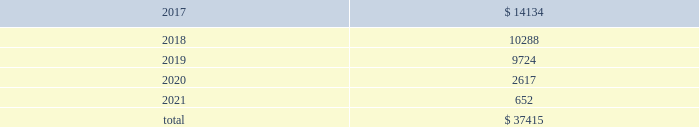Table of contents 17 .
Unconditional purchase obligations the company has entered into various unconditional purchase obligations which primarily include software licenses and long- term purchase contracts for network , communication and office maintenance services .
The company expended $ 7.2 million , $ 5.3 million and $ 2.9 million related to unconditional purchase obligations that existed as of the beginning of each year for the years ended december 31 , 2016 , 2015 and 2014 , respectively .
Future expenditures under unconditional purchase obligations in effect as of december 31 , 2016 are as follows : ( in thousands ) .
18 .
Restructuring during the fourth quarter of 2016 , the company initiated workforce realignment activities .
The company incurred $ 3.4 million in restructuring charges , or $ 2.4 million net of tax , during the year ended december 31 , 2016 .
The company expects to incur additional charges of $ 10 million - $ 15 million , or $ 7 million - $ 10 million net of tax , primarily during the first quarter of 2017 .
19 .
Employment-related settlement on february 15 , 2017 , the company entered into an employment-related settlement agreement .
In connection with the settlement agreement , the company will make a lump-sum payment of $ 4.7 million .
The charges related to this agreement are included in selling , general and administrative expense in the 2016 consolidated statement of income .
As part of the settlement agreement , all the claims initiated against the company will be withdrawn and a general release of all claims in favor of the company and all of its related entities was executed .
20 .
Contingencies and commitments the company is subject to various investigations , claims and legal proceedings that arise in the ordinary course of business , including commercial disputes , labor and employment matters , tax audits , alleged infringement of intellectual property rights and other matters .
In the opinion of the company , the resolution of pending matters is not expected to have a material adverse effect on the company's consolidated results of operations , cash flows or financial position .
However , each of these matters is subject to various uncertainties and it is possible that an unfavorable resolution of one or more of these proceedings could materially affect the company's results of operations , cash flows or financial position .
An indian subsidiary of the company has several service tax audits pending that have resulted in formal inquiries being received on transactions through mid-2012 .
The company could incur tax charges and related liabilities , including those related to the service tax audit case , of approximately $ 7 million .
The service tax issues raised in the company 2019s notices and inquiries are very similar to the case , m/s microsoft corporation ( i ) ( p ) ltd .
Vs commissioner of service tax , new delhi , wherein the delhi customs , excise and service tax appellate tribunal ( cestat ) has passed a favorable ruling to microsoft .
The company can provide no assurances on whether the microsoft case 2019s favorable ruling will be challenged in higher courts or on the impact that the present microsoft case 2019s decision will have on the company 2019s cases .
The company is uncertain as to when these service tax matters will be concluded .
A french subsidiary of the company received notice that the french taxing authority rejected the company's 2012 research and development credit .
The company has contested the decision .
However , if the company does not receive a favorable outcome , it could incur charges of approximately $ 0.8 million .
In addition , an unfavorable outcome could result in the authorities reviewing or rejecting $ 3.8 million of similar research and development credits for 2013 through the current year that are currently reflected as an asset .
The company can provide no assurances on the timing or outcome of this matter. .
What is the percentage decrease in expenditures from 2017-2018? 
Computations: ((14134 - 10288) / 14134)
Answer: 0.27211. 